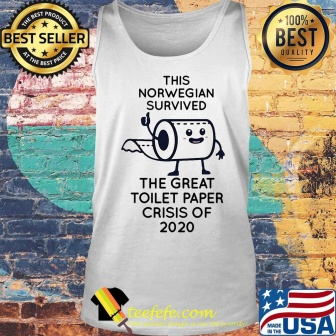What can you infer about the cultural or historical significance of this tank top? The tank top humorously captures a unique moment in recent history—the early days of the COVID-19 pandemic, specifically the toilet paper shortages that became a widespread and memorable phenomenon. The text on the tank top, 'This Norwegian survived the great toilet paper crisis of 2020,' reflects a shared global experience, highlighting how people found humor and camaraderie even in challenging times. The American flag and the badges indicating 'best seller' and '100% best quality' suggest a sense of pride and high demand for this nostalgic and comical product, turning a mundane item of clothing into a piece of cultural memorabilia. Tell me more about the design elements and their significance. The design elements of the tank top are carefully chosen to evoke both humor and nostalgia. The cartoon of the toilet paper roll with arms and legs adds a playful touch, making the mundane item anthropomorphic and relatable. Its triumphant pose symbolizes overcoming an unusual crisis. The text 'This Norwegian survived the great toilet paper crisis of 2020' is not only humorous but also serves as a badge of honor for those who experienced the shortages. The brick wall backdrop adds a rustic and authentic feel, while the American flag brings in a patriotic element. The 'best seller' and '100% best quality' badges further emphasize the product's popularity and quality, making it not just a piece of clothing but a conversation starter and a memento from a unique period in history. 